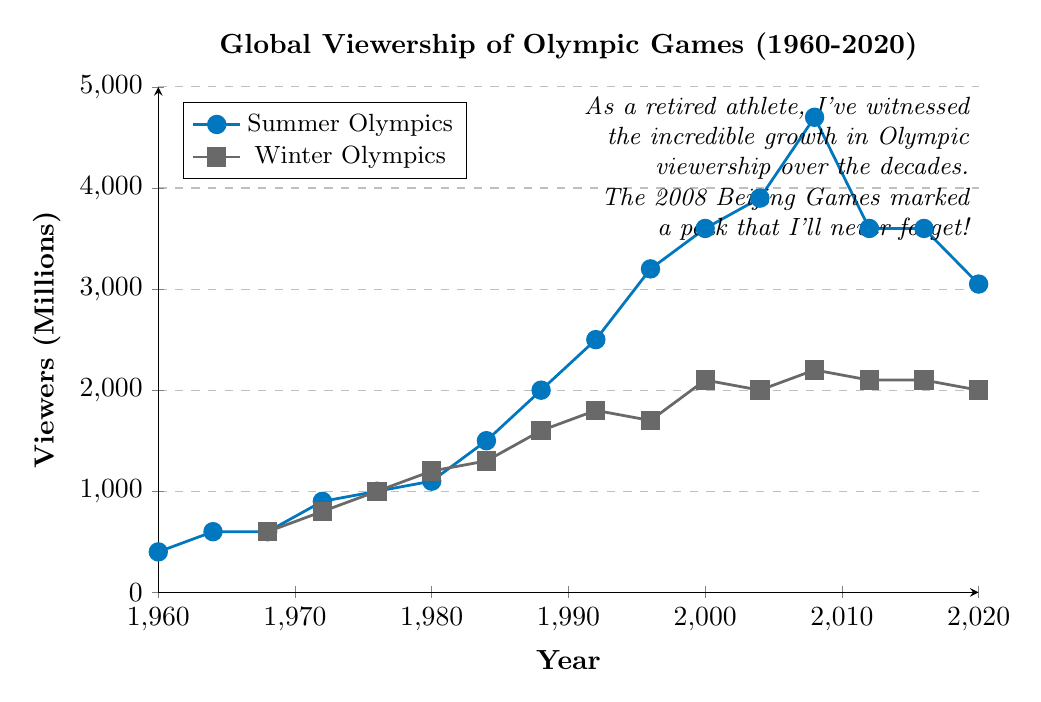Which year had the highest viewership for the Summer Olympics? To find the year with the highest viewership for the Summer Olympics, look for the peak point in the line graph for the Summer Olympics. The highest point is at 2008.
Answer: 2008 Did the Winter Olympics ever have higher viewership than the Summer Olympics? To determine if the Winter Olympics had higher viewership than the Summer Olympics at any point, compare the two lines throughout the entire timeline. The graph shows that the Summer Olympics always had higher viewership.
Answer: No What is the viewership difference between the Summer and Winter Olympics in 1988? Look at the values for 1988 in both Summer and Winter Olympics lines. The Summer had 2000 million viewers, and the Winter had 1600 million viewers. The difference is 2000 - 1600 = 400.
Answer: 400 Which period shows a significant drop in the Summer Olympics viewership? Observe the trend of the Summer Olympics line graph. There is a significant drop between 2008 and 2012 from 4700 million viewers to 3600 million viewers.
Answer: 2008-2012 How did the viewership change for the Winter Olympics between 1968 and 1972? Check the viewership numbers for the Winter Olympics in the years 1968 and 1972. In 1968, there were 600 million viewers, and in 1972, there were 800 million viewers. The viewership increased by 800 - 600 = 200.
Answer: Increased by 200 Compare the viewership of the Summer Olympics in 1976 and 2016. Look at the viewership numbers for the Summer Olympics in 1976 and 2016. In 1976, it was 1000 million, while in 2016, it was 3600 million. 2016 had 3600 - 1000 = 2600 million more viewers than 1976.
Answer: 2016 had 2600 million more Which Olympic event had a higher viewership in 2000, and by how much? Look at the viewership numbers for both the Summer and Winter Olympics in 2000. The Summer Olympics had 3600 million viewers, and the Winter Olympics had 2100 million viewers. The difference is 3600 - 2100 = 1500.
Answer: Summer Olympics by 1500 During which decade did the Summer Olympics see the largest increase in viewership? Observe the increase in the Summer Olympics viewership across each decade. The largest increase was between 1980 (1100 million) and 1990 (2500 million), which is a rise of 2500 - 1100 = 1400.
Answer: 1980-1990 What was the average viewership of the Winter Olympics between 1992 and 2004? Sum the viewership numbers for the Winter Olympics for the years 1992, 1996, 2000, and 2004, then divide by the number of events. (1800 + 1700 + 2100 + 2000) / 4 = 7600 / 4 = 1900.
Answer: 1900 Compare the trend of viewership for both the Summer and Winter Olympics from 1968 to 1988. Observe the trend lines from 1968 to 1988 for both events. Both lines show a general increase in viewership, with the Summer Olympics growing from 600 to 2000 million and the Winter Olympics from 600 to 1600 million.
Answer: Both increased 